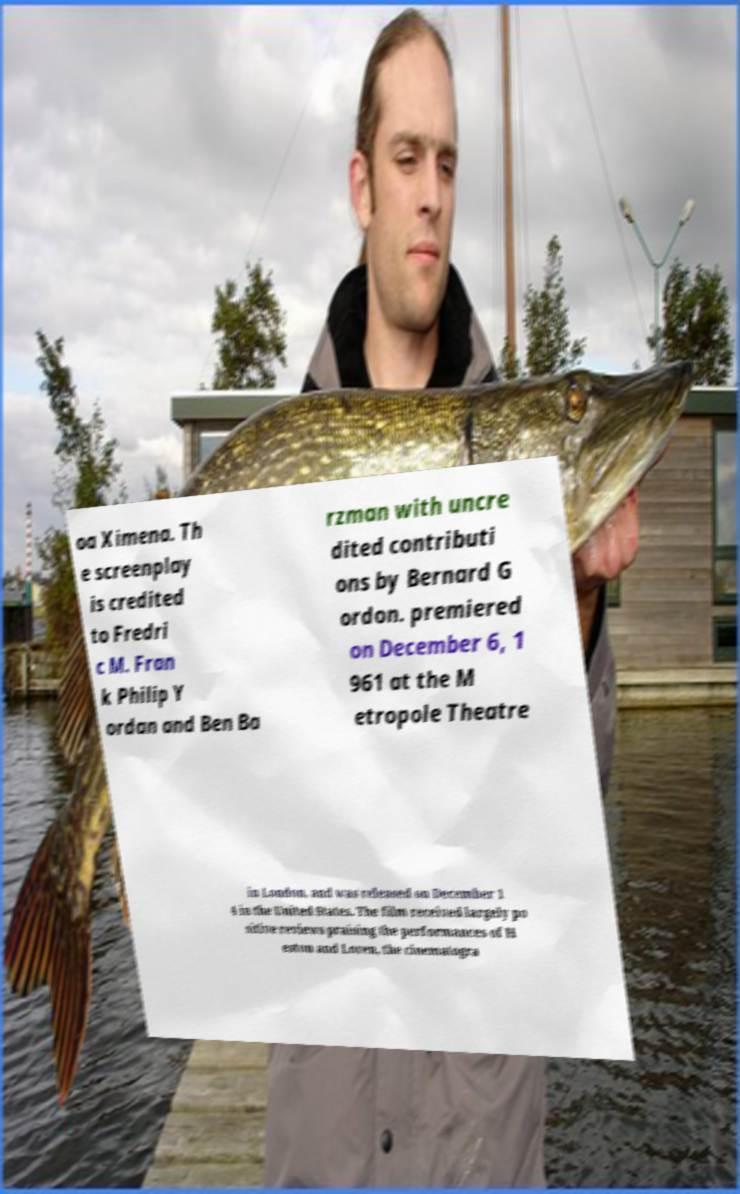There's text embedded in this image that I need extracted. Can you transcribe it verbatim? oa Ximena. Th e screenplay is credited to Fredri c M. Fran k Philip Y ordan and Ben Ba rzman with uncre dited contributi ons by Bernard G ordon. premiered on December 6, 1 961 at the M etropole Theatre in London, and was released on December 1 4 in the United States. The film received largely po sitive reviews praising the performances of H eston and Loren, the cinematogra 